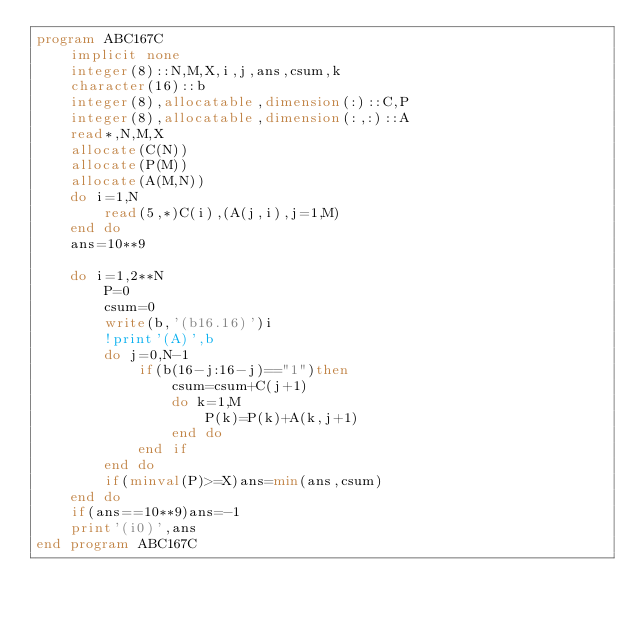Convert code to text. <code><loc_0><loc_0><loc_500><loc_500><_FORTRAN_>program ABC167C
    implicit none
    integer(8)::N,M,X,i,j,ans,csum,k
    character(16)::b
    integer(8),allocatable,dimension(:)::C,P
    integer(8),allocatable,dimension(:,:)::A
    read*,N,M,X
    allocate(C(N))
    allocate(P(M))
    allocate(A(M,N))
    do i=1,N
        read(5,*)C(i),(A(j,i),j=1,M)
    end do
    ans=10**9

    do i=1,2**N
        P=0
        csum=0
        write(b,'(b16.16)')i
        !print'(A)',b
        do j=0,N-1
            if(b(16-j:16-j)=="1")then
                csum=csum+C(j+1)
                do k=1,M
                    P(k)=P(k)+A(k,j+1)
                end do
            end if
        end do
        if(minval(P)>=X)ans=min(ans,csum)
    end do
    if(ans==10**9)ans=-1
    print'(i0)',ans
end program ABC167C</code> 